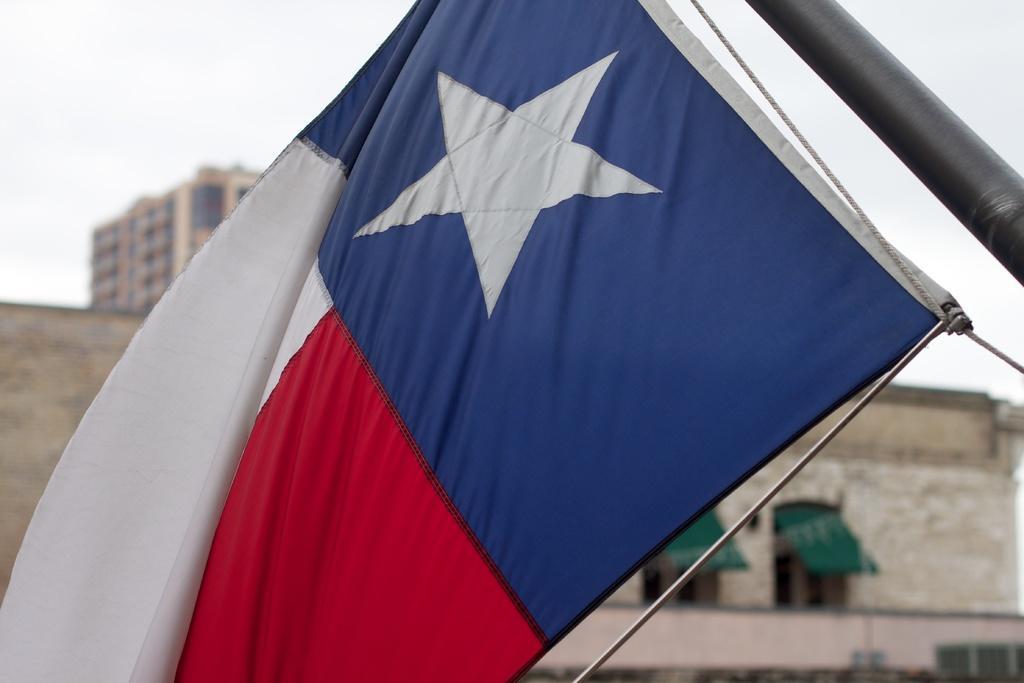In one or two sentences, can you explain what this image depicts? In the center of the image we can see a flag. In the background of the image we can see the buildings, windows, board, rod. At the top of the image we can see the sky. 